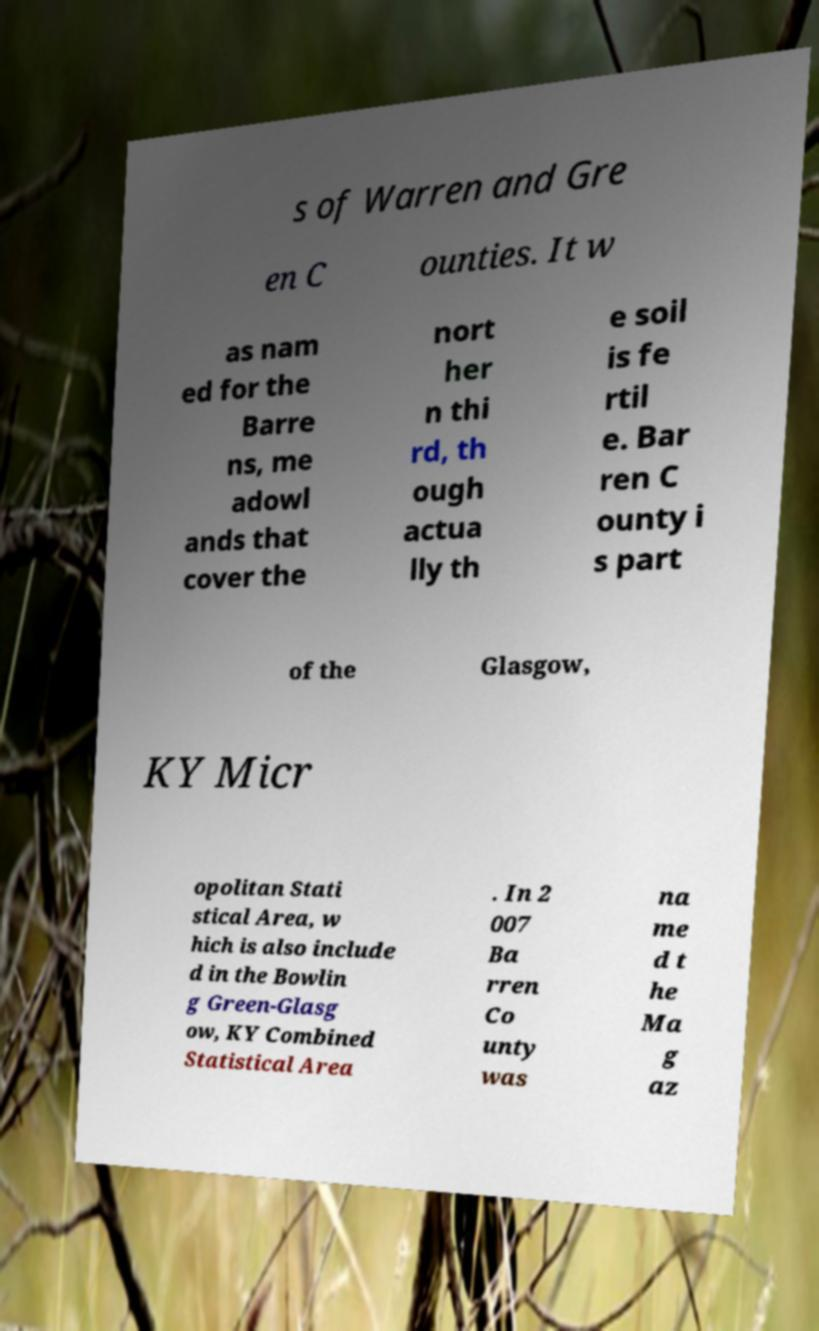Can you accurately transcribe the text from the provided image for me? s of Warren and Gre en C ounties. It w as nam ed for the Barre ns, me adowl ands that cover the nort her n thi rd, th ough actua lly th e soil is fe rtil e. Bar ren C ounty i s part of the Glasgow, KY Micr opolitan Stati stical Area, w hich is also include d in the Bowlin g Green-Glasg ow, KY Combined Statistical Area . In 2 007 Ba rren Co unty was na me d t he Ma g az 